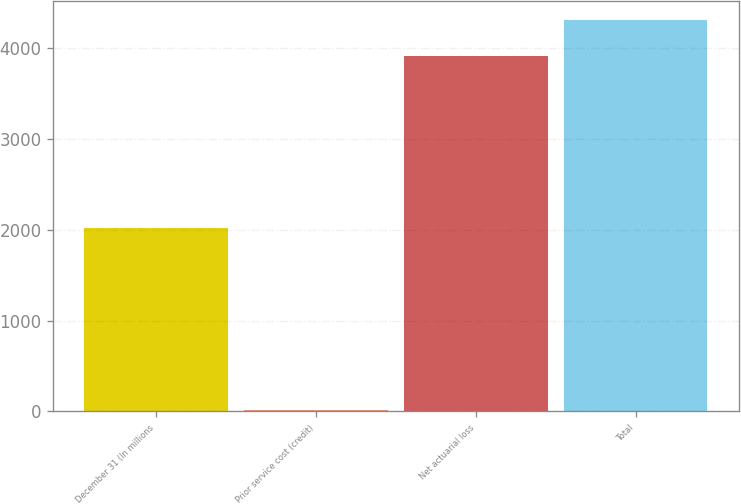<chart> <loc_0><loc_0><loc_500><loc_500><bar_chart><fcel>December 31 (In millions<fcel>Prior service cost (credit)<fcel>Net actuarial loss<fcel>Total<nl><fcel>2018<fcel>14<fcel>3918<fcel>4309.8<nl></chart> 